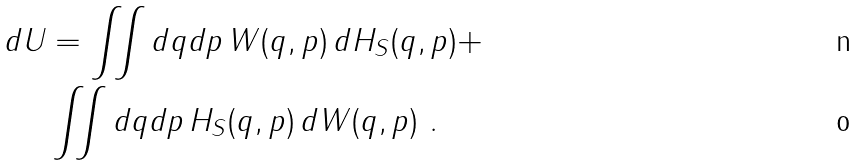Convert formula to latex. <formula><loc_0><loc_0><loc_500><loc_500>d U & = \iint d q d p \, W ( q , p ) \, d H _ { S } ( q , p ) + \\ & \iint d q d p \, H _ { S } ( q , p ) \, d W ( q , p ) \ .</formula> 